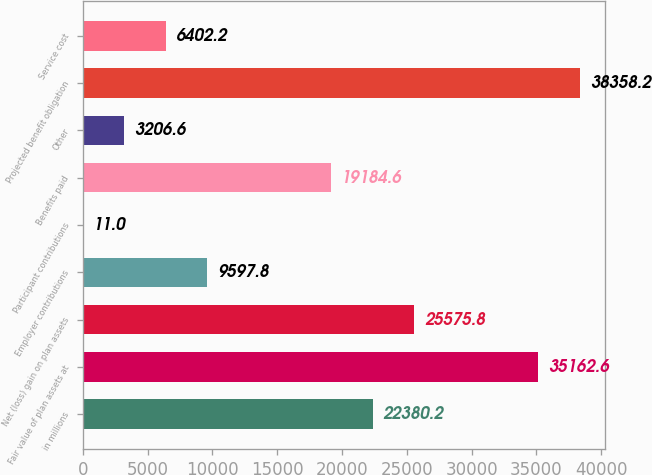Convert chart. <chart><loc_0><loc_0><loc_500><loc_500><bar_chart><fcel>in millions<fcel>Fair value of plan assets at<fcel>Net (loss) gain on plan assets<fcel>Employer contributions<fcel>Participant contributions<fcel>Benefits paid<fcel>Other<fcel>Projected benefit obligation<fcel>Service cost<nl><fcel>22380.2<fcel>35162.6<fcel>25575.8<fcel>9597.8<fcel>11<fcel>19184.6<fcel>3206.6<fcel>38358.2<fcel>6402.2<nl></chart> 